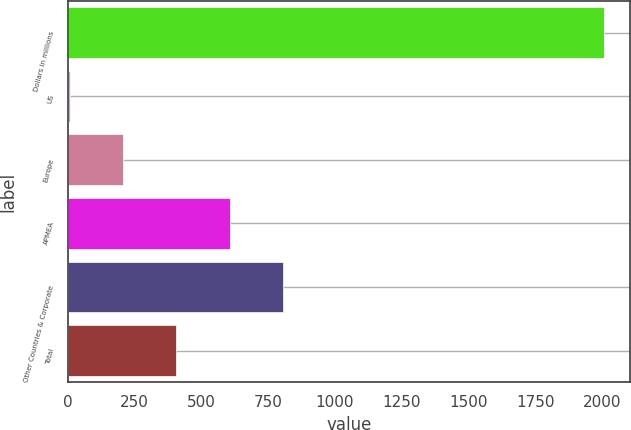<chart> <loc_0><loc_0><loc_500><loc_500><bar_chart><fcel>Dollars in millions<fcel>US<fcel>Europe<fcel>APMEA<fcel>Other Countries & Corporate<fcel>Total<nl><fcel>2007<fcel>6<fcel>206.1<fcel>606.3<fcel>806.4<fcel>406.2<nl></chart> 